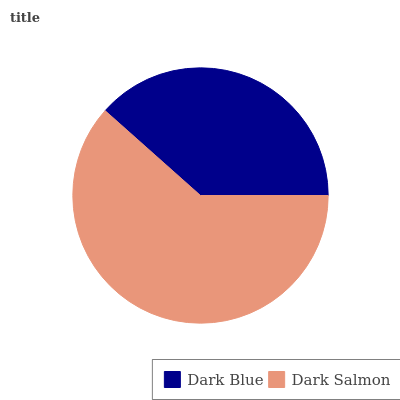Is Dark Blue the minimum?
Answer yes or no. Yes. Is Dark Salmon the maximum?
Answer yes or no. Yes. Is Dark Salmon the minimum?
Answer yes or no. No. Is Dark Salmon greater than Dark Blue?
Answer yes or no. Yes. Is Dark Blue less than Dark Salmon?
Answer yes or no. Yes. Is Dark Blue greater than Dark Salmon?
Answer yes or no. No. Is Dark Salmon less than Dark Blue?
Answer yes or no. No. Is Dark Salmon the high median?
Answer yes or no. Yes. Is Dark Blue the low median?
Answer yes or no. Yes. Is Dark Blue the high median?
Answer yes or no. No. Is Dark Salmon the low median?
Answer yes or no. No. 